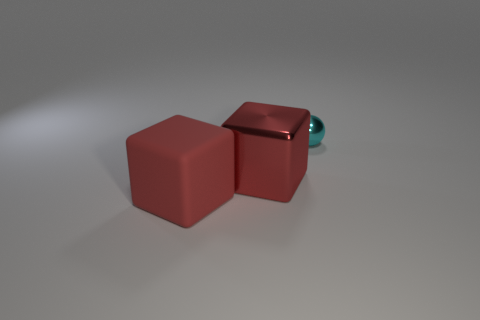Do the metallic object that is in front of the small cyan metallic object and the small cyan object that is behind the rubber cube have the same shape?
Keep it short and to the point. No. What number of other things are the same color as the tiny thing?
Your answer should be very brief. 0. Is the big object on the left side of the big red shiny thing made of the same material as the thing on the right side of the large metal cube?
Your answer should be compact. No. Is the number of big red shiny things that are on the left side of the large shiny cube the same as the number of balls on the left side of the tiny cyan sphere?
Offer a terse response. Yes. What material is the object on the left side of the red shiny thing?
Provide a short and direct response. Rubber. Are there any other things that are the same size as the matte object?
Ensure brevity in your answer.  Yes. Is the number of big blue balls less than the number of cyan shiny balls?
Offer a very short reply. Yes. What shape is the object that is both to the left of the cyan sphere and right of the big red matte cube?
Your answer should be very brief. Cube. How many tiny cyan metallic objects are there?
Make the answer very short. 1. There is a red object on the right side of the large red matte block that is left of the metallic thing that is in front of the small sphere; what is its material?
Your answer should be very brief. Metal. 